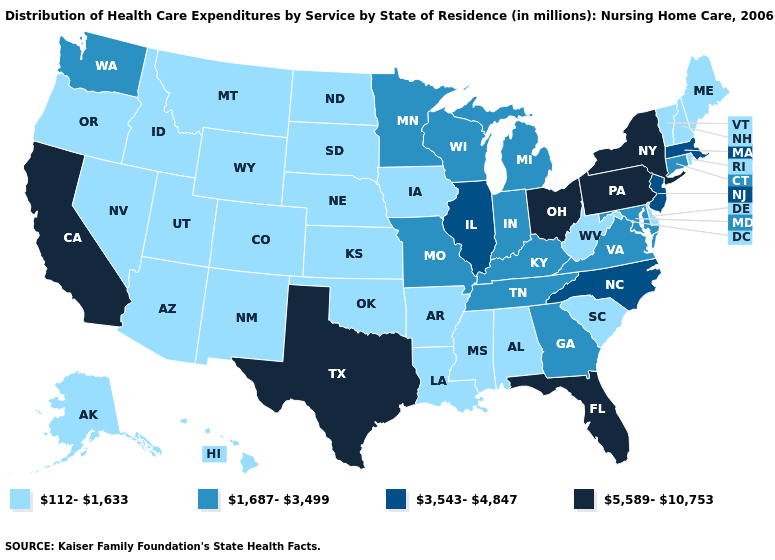What is the lowest value in states that border Ohio?
Quick response, please. 112-1,633. Does Rhode Island have the highest value in the Northeast?
Be succinct. No. Does Wisconsin have the lowest value in the USA?
Be succinct. No. Among the states that border Indiana , does Illinois have the highest value?
Concise answer only. No. Name the states that have a value in the range 1,687-3,499?
Be succinct. Connecticut, Georgia, Indiana, Kentucky, Maryland, Michigan, Minnesota, Missouri, Tennessee, Virginia, Washington, Wisconsin. Name the states that have a value in the range 5,589-10,753?
Quick response, please. California, Florida, New York, Ohio, Pennsylvania, Texas. Among the states that border Oklahoma , which have the lowest value?
Quick response, please. Arkansas, Colorado, Kansas, New Mexico. Which states hav the highest value in the South?
Concise answer only. Florida, Texas. What is the lowest value in the USA?
Be succinct. 112-1,633. Does Nebraska have a lower value than Washington?
Quick response, please. Yes. Name the states that have a value in the range 3,543-4,847?
Write a very short answer. Illinois, Massachusetts, New Jersey, North Carolina. What is the value of Rhode Island?
Keep it brief. 112-1,633. What is the value of Nebraska?
Give a very brief answer. 112-1,633. What is the value of Connecticut?
Keep it brief. 1,687-3,499. What is the highest value in the West ?
Be succinct. 5,589-10,753. 